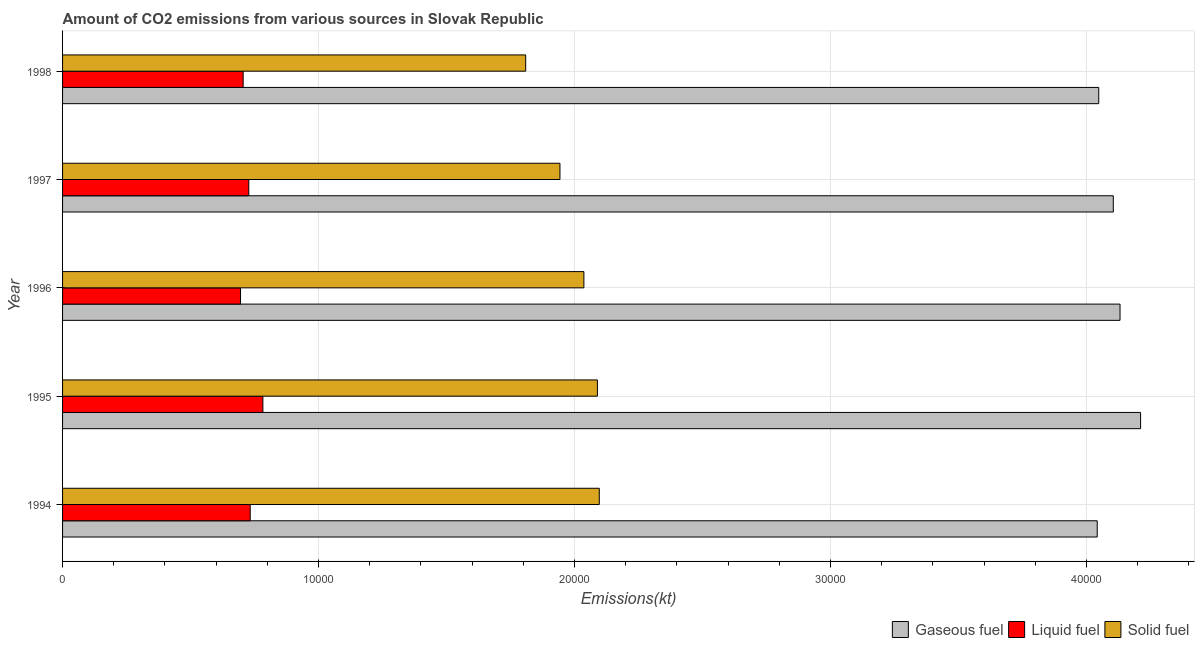How many different coloured bars are there?
Ensure brevity in your answer.  3. Are the number of bars per tick equal to the number of legend labels?
Make the answer very short. Yes. What is the amount of co2 emissions from gaseous fuel in 1997?
Your answer should be very brief. 4.10e+04. Across all years, what is the maximum amount of co2 emissions from liquid fuel?
Ensure brevity in your answer.  7825.38. Across all years, what is the minimum amount of co2 emissions from gaseous fuel?
Your answer should be very brief. 4.04e+04. What is the total amount of co2 emissions from liquid fuel in the graph?
Offer a very short reply. 3.64e+04. What is the difference between the amount of co2 emissions from solid fuel in 1997 and that in 1998?
Your response must be concise. 1338.45. What is the difference between the amount of co2 emissions from liquid fuel in 1997 and the amount of co2 emissions from gaseous fuel in 1994?
Offer a terse response. -3.31e+04. What is the average amount of co2 emissions from solid fuel per year?
Offer a very short reply. 2.00e+04. In the year 1997, what is the difference between the amount of co2 emissions from gaseous fuel and amount of co2 emissions from liquid fuel?
Provide a succinct answer. 3.38e+04. In how many years, is the amount of co2 emissions from solid fuel greater than 6000 kt?
Offer a terse response. 5. What is the ratio of the amount of co2 emissions from solid fuel in 1995 to that in 1997?
Give a very brief answer. 1.07. Is the difference between the amount of co2 emissions from solid fuel in 1994 and 1997 greater than the difference between the amount of co2 emissions from liquid fuel in 1994 and 1997?
Your answer should be compact. Yes. What is the difference between the highest and the second highest amount of co2 emissions from gaseous fuel?
Provide a succinct answer. 803.07. What is the difference between the highest and the lowest amount of co2 emissions from solid fuel?
Your response must be concise. 2874.93. In how many years, is the amount of co2 emissions from gaseous fuel greater than the average amount of co2 emissions from gaseous fuel taken over all years?
Your answer should be very brief. 2. What does the 1st bar from the top in 1994 represents?
Your answer should be very brief. Solid fuel. What does the 3rd bar from the bottom in 1995 represents?
Make the answer very short. Solid fuel. How many bars are there?
Your answer should be very brief. 15. Are all the bars in the graph horizontal?
Provide a short and direct response. Yes. How many years are there in the graph?
Offer a very short reply. 5. What is the difference between two consecutive major ticks on the X-axis?
Offer a very short reply. 10000. Does the graph contain grids?
Keep it short and to the point. Yes. How many legend labels are there?
Offer a terse response. 3. What is the title of the graph?
Offer a terse response. Amount of CO2 emissions from various sources in Slovak Republic. What is the label or title of the X-axis?
Ensure brevity in your answer.  Emissions(kt). What is the Emissions(kt) in Gaseous fuel in 1994?
Your response must be concise. 4.04e+04. What is the Emissions(kt) in Liquid fuel in 1994?
Offer a terse response. 7330.33. What is the Emissions(kt) of Solid fuel in 1994?
Your answer should be compact. 2.10e+04. What is the Emissions(kt) in Gaseous fuel in 1995?
Your answer should be compact. 4.21e+04. What is the Emissions(kt) in Liquid fuel in 1995?
Provide a short and direct response. 7825.38. What is the Emissions(kt) in Solid fuel in 1995?
Your answer should be compact. 2.09e+04. What is the Emissions(kt) of Gaseous fuel in 1996?
Your response must be concise. 4.13e+04. What is the Emissions(kt) of Liquid fuel in 1996?
Give a very brief answer. 6952.63. What is the Emissions(kt) in Solid fuel in 1996?
Ensure brevity in your answer.  2.04e+04. What is the Emissions(kt) of Gaseous fuel in 1997?
Your answer should be compact. 4.10e+04. What is the Emissions(kt) in Liquid fuel in 1997?
Your response must be concise. 7275.33. What is the Emissions(kt) in Solid fuel in 1997?
Your response must be concise. 1.94e+04. What is the Emissions(kt) of Gaseous fuel in 1998?
Offer a very short reply. 4.05e+04. What is the Emissions(kt) in Liquid fuel in 1998?
Your response must be concise. 7055.31. What is the Emissions(kt) of Solid fuel in 1998?
Make the answer very short. 1.81e+04. Across all years, what is the maximum Emissions(kt) of Gaseous fuel?
Provide a succinct answer. 4.21e+04. Across all years, what is the maximum Emissions(kt) of Liquid fuel?
Your response must be concise. 7825.38. Across all years, what is the maximum Emissions(kt) in Solid fuel?
Give a very brief answer. 2.10e+04. Across all years, what is the minimum Emissions(kt) in Gaseous fuel?
Your answer should be very brief. 4.04e+04. Across all years, what is the minimum Emissions(kt) in Liquid fuel?
Provide a short and direct response. 6952.63. Across all years, what is the minimum Emissions(kt) of Solid fuel?
Provide a short and direct response. 1.81e+04. What is the total Emissions(kt) of Gaseous fuel in the graph?
Your response must be concise. 2.05e+05. What is the total Emissions(kt) in Liquid fuel in the graph?
Offer a very short reply. 3.64e+04. What is the total Emissions(kt) in Solid fuel in the graph?
Offer a very short reply. 9.98e+04. What is the difference between the Emissions(kt) of Gaseous fuel in 1994 and that in 1995?
Your response must be concise. -1694.15. What is the difference between the Emissions(kt) of Liquid fuel in 1994 and that in 1995?
Offer a very short reply. -495.05. What is the difference between the Emissions(kt) of Solid fuel in 1994 and that in 1995?
Make the answer very short. 73.34. What is the difference between the Emissions(kt) in Gaseous fuel in 1994 and that in 1996?
Provide a short and direct response. -891.08. What is the difference between the Emissions(kt) in Liquid fuel in 1994 and that in 1996?
Your answer should be very brief. 377.7. What is the difference between the Emissions(kt) in Solid fuel in 1994 and that in 1996?
Provide a succinct answer. 601.39. What is the difference between the Emissions(kt) of Gaseous fuel in 1994 and that in 1997?
Offer a very short reply. -627.06. What is the difference between the Emissions(kt) in Liquid fuel in 1994 and that in 1997?
Offer a very short reply. 55.01. What is the difference between the Emissions(kt) of Solid fuel in 1994 and that in 1997?
Give a very brief answer. 1536.47. What is the difference between the Emissions(kt) of Gaseous fuel in 1994 and that in 1998?
Ensure brevity in your answer.  -58.67. What is the difference between the Emissions(kt) of Liquid fuel in 1994 and that in 1998?
Provide a succinct answer. 275.02. What is the difference between the Emissions(kt) in Solid fuel in 1994 and that in 1998?
Ensure brevity in your answer.  2874.93. What is the difference between the Emissions(kt) of Gaseous fuel in 1995 and that in 1996?
Your answer should be very brief. 803.07. What is the difference between the Emissions(kt) in Liquid fuel in 1995 and that in 1996?
Your response must be concise. 872.75. What is the difference between the Emissions(kt) in Solid fuel in 1995 and that in 1996?
Give a very brief answer. 528.05. What is the difference between the Emissions(kt) in Gaseous fuel in 1995 and that in 1997?
Provide a short and direct response. 1067.1. What is the difference between the Emissions(kt) in Liquid fuel in 1995 and that in 1997?
Offer a terse response. 550.05. What is the difference between the Emissions(kt) in Solid fuel in 1995 and that in 1997?
Your answer should be very brief. 1463.13. What is the difference between the Emissions(kt) in Gaseous fuel in 1995 and that in 1998?
Make the answer very short. 1635.48. What is the difference between the Emissions(kt) in Liquid fuel in 1995 and that in 1998?
Offer a terse response. 770.07. What is the difference between the Emissions(kt) in Solid fuel in 1995 and that in 1998?
Give a very brief answer. 2801.59. What is the difference between the Emissions(kt) of Gaseous fuel in 1996 and that in 1997?
Your answer should be very brief. 264.02. What is the difference between the Emissions(kt) in Liquid fuel in 1996 and that in 1997?
Your answer should be very brief. -322.7. What is the difference between the Emissions(kt) in Solid fuel in 1996 and that in 1997?
Your response must be concise. 935.09. What is the difference between the Emissions(kt) in Gaseous fuel in 1996 and that in 1998?
Keep it short and to the point. 832.41. What is the difference between the Emissions(kt) in Liquid fuel in 1996 and that in 1998?
Give a very brief answer. -102.68. What is the difference between the Emissions(kt) in Solid fuel in 1996 and that in 1998?
Make the answer very short. 2273.54. What is the difference between the Emissions(kt) of Gaseous fuel in 1997 and that in 1998?
Ensure brevity in your answer.  568.38. What is the difference between the Emissions(kt) in Liquid fuel in 1997 and that in 1998?
Keep it short and to the point. 220.02. What is the difference between the Emissions(kt) in Solid fuel in 1997 and that in 1998?
Offer a very short reply. 1338.45. What is the difference between the Emissions(kt) of Gaseous fuel in 1994 and the Emissions(kt) of Liquid fuel in 1995?
Keep it short and to the point. 3.26e+04. What is the difference between the Emissions(kt) in Gaseous fuel in 1994 and the Emissions(kt) in Solid fuel in 1995?
Your answer should be very brief. 1.95e+04. What is the difference between the Emissions(kt) in Liquid fuel in 1994 and the Emissions(kt) in Solid fuel in 1995?
Give a very brief answer. -1.36e+04. What is the difference between the Emissions(kt) in Gaseous fuel in 1994 and the Emissions(kt) in Liquid fuel in 1996?
Your response must be concise. 3.35e+04. What is the difference between the Emissions(kt) in Gaseous fuel in 1994 and the Emissions(kt) in Solid fuel in 1996?
Offer a very short reply. 2.01e+04. What is the difference between the Emissions(kt) of Liquid fuel in 1994 and the Emissions(kt) of Solid fuel in 1996?
Offer a terse response. -1.30e+04. What is the difference between the Emissions(kt) in Gaseous fuel in 1994 and the Emissions(kt) in Liquid fuel in 1997?
Offer a very short reply. 3.31e+04. What is the difference between the Emissions(kt) of Gaseous fuel in 1994 and the Emissions(kt) of Solid fuel in 1997?
Your response must be concise. 2.10e+04. What is the difference between the Emissions(kt) of Liquid fuel in 1994 and the Emissions(kt) of Solid fuel in 1997?
Your response must be concise. -1.21e+04. What is the difference between the Emissions(kt) in Gaseous fuel in 1994 and the Emissions(kt) in Liquid fuel in 1998?
Your answer should be compact. 3.34e+04. What is the difference between the Emissions(kt) in Gaseous fuel in 1994 and the Emissions(kt) in Solid fuel in 1998?
Keep it short and to the point. 2.23e+04. What is the difference between the Emissions(kt) in Liquid fuel in 1994 and the Emissions(kt) in Solid fuel in 1998?
Make the answer very short. -1.08e+04. What is the difference between the Emissions(kt) of Gaseous fuel in 1995 and the Emissions(kt) of Liquid fuel in 1996?
Your response must be concise. 3.52e+04. What is the difference between the Emissions(kt) of Gaseous fuel in 1995 and the Emissions(kt) of Solid fuel in 1996?
Your answer should be very brief. 2.17e+04. What is the difference between the Emissions(kt) in Liquid fuel in 1995 and the Emissions(kt) in Solid fuel in 1996?
Ensure brevity in your answer.  -1.25e+04. What is the difference between the Emissions(kt) of Gaseous fuel in 1995 and the Emissions(kt) of Liquid fuel in 1997?
Make the answer very short. 3.48e+04. What is the difference between the Emissions(kt) in Gaseous fuel in 1995 and the Emissions(kt) in Solid fuel in 1997?
Ensure brevity in your answer.  2.27e+04. What is the difference between the Emissions(kt) in Liquid fuel in 1995 and the Emissions(kt) in Solid fuel in 1997?
Your answer should be compact. -1.16e+04. What is the difference between the Emissions(kt) in Gaseous fuel in 1995 and the Emissions(kt) in Liquid fuel in 1998?
Offer a terse response. 3.51e+04. What is the difference between the Emissions(kt) in Gaseous fuel in 1995 and the Emissions(kt) in Solid fuel in 1998?
Provide a short and direct response. 2.40e+04. What is the difference between the Emissions(kt) of Liquid fuel in 1995 and the Emissions(kt) of Solid fuel in 1998?
Your response must be concise. -1.03e+04. What is the difference between the Emissions(kt) in Gaseous fuel in 1996 and the Emissions(kt) in Liquid fuel in 1997?
Keep it short and to the point. 3.40e+04. What is the difference between the Emissions(kt) of Gaseous fuel in 1996 and the Emissions(kt) of Solid fuel in 1997?
Your answer should be compact. 2.19e+04. What is the difference between the Emissions(kt) of Liquid fuel in 1996 and the Emissions(kt) of Solid fuel in 1997?
Your answer should be compact. -1.25e+04. What is the difference between the Emissions(kt) in Gaseous fuel in 1996 and the Emissions(kt) in Liquid fuel in 1998?
Give a very brief answer. 3.43e+04. What is the difference between the Emissions(kt) in Gaseous fuel in 1996 and the Emissions(kt) in Solid fuel in 1998?
Give a very brief answer. 2.32e+04. What is the difference between the Emissions(kt) of Liquid fuel in 1996 and the Emissions(kt) of Solid fuel in 1998?
Keep it short and to the point. -1.11e+04. What is the difference between the Emissions(kt) in Gaseous fuel in 1997 and the Emissions(kt) in Liquid fuel in 1998?
Give a very brief answer. 3.40e+04. What is the difference between the Emissions(kt) of Gaseous fuel in 1997 and the Emissions(kt) of Solid fuel in 1998?
Offer a very short reply. 2.30e+04. What is the difference between the Emissions(kt) of Liquid fuel in 1997 and the Emissions(kt) of Solid fuel in 1998?
Your response must be concise. -1.08e+04. What is the average Emissions(kt) in Gaseous fuel per year?
Make the answer very short. 4.11e+04. What is the average Emissions(kt) in Liquid fuel per year?
Offer a very short reply. 7287.8. What is the average Emissions(kt) in Solid fuel per year?
Give a very brief answer. 2.00e+04. In the year 1994, what is the difference between the Emissions(kt) in Gaseous fuel and Emissions(kt) in Liquid fuel?
Give a very brief answer. 3.31e+04. In the year 1994, what is the difference between the Emissions(kt) in Gaseous fuel and Emissions(kt) in Solid fuel?
Provide a short and direct response. 1.95e+04. In the year 1994, what is the difference between the Emissions(kt) in Liquid fuel and Emissions(kt) in Solid fuel?
Your response must be concise. -1.36e+04. In the year 1995, what is the difference between the Emissions(kt) of Gaseous fuel and Emissions(kt) of Liquid fuel?
Your response must be concise. 3.43e+04. In the year 1995, what is the difference between the Emissions(kt) of Gaseous fuel and Emissions(kt) of Solid fuel?
Give a very brief answer. 2.12e+04. In the year 1995, what is the difference between the Emissions(kt) in Liquid fuel and Emissions(kt) in Solid fuel?
Ensure brevity in your answer.  -1.31e+04. In the year 1996, what is the difference between the Emissions(kt) of Gaseous fuel and Emissions(kt) of Liquid fuel?
Make the answer very short. 3.44e+04. In the year 1996, what is the difference between the Emissions(kt) of Gaseous fuel and Emissions(kt) of Solid fuel?
Keep it short and to the point. 2.09e+04. In the year 1996, what is the difference between the Emissions(kt) in Liquid fuel and Emissions(kt) in Solid fuel?
Provide a short and direct response. -1.34e+04. In the year 1997, what is the difference between the Emissions(kt) in Gaseous fuel and Emissions(kt) in Liquid fuel?
Provide a succinct answer. 3.38e+04. In the year 1997, what is the difference between the Emissions(kt) in Gaseous fuel and Emissions(kt) in Solid fuel?
Keep it short and to the point. 2.16e+04. In the year 1997, what is the difference between the Emissions(kt) of Liquid fuel and Emissions(kt) of Solid fuel?
Ensure brevity in your answer.  -1.22e+04. In the year 1998, what is the difference between the Emissions(kt) of Gaseous fuel and Emissions(kt) of Liquid fuel?
Make the answer very short. 3.34e+04. In the year 1998, what is the difference between the Emissions(kt) in Gaseous fuel and Emissions(kt) in Solid fuel?
Offer a very short reply. 2.24e+04. In the year 1998, what is the difference between the Emissions(kt) of Liquid fuel and Emissions(kt) of Solid fuel?
Your response must be concise. -1.10e+04. What is the ratio of the Emissions(kt) of Gaseous fuel in 1994 to that in 1995?
Your answer should be compact. 0.96. What is the ratio of the Emissions(kt) of Liquid fuel in 1994 to that in 1995?
Give a very brief answer. 0.94. What is the ratio of the Emissions(kt) in Gaseous fuel in 1994 to that in 1996?
Ensure brevity in your answer.  0.98. What is the ratio of the Emissions(kt) of Liquid fuel in 1994 to that in 1996?
Your answer should be compact. 1.05. What is the ratio of the Emissions(kt) of Solid fuel in 1994 to that in 1996?
Offer a terse response. 1.03. What is the ratio of the Emissions(kt) in Gaseous fuel in 1994 to that in 1997?
Keep it short and to the point. 0.98. What is the ratio of the Emissions(kt) of Liquid fuel in 1994 to that in 1997?
Offer a terse response. 1.01. What is the ratio of the Emissions(kt) of Solid fuel in 1994 to that in 1997?
Offer a terse response. 1.08. What is the ratio of the Emissions(kt) of Liquid fuel in 1994 to that in 1998?
Your response must be concise. 1.04. What is the ratio of the Emissions(kt) in Solid fuel in 1994 to that in 1998?
Ensure brevity in your answer.  1.16. What is the ratio of the Emissions(kt) of Gaseous fuel in 1995 to that in 1996?
Keep it short and to the point. 1.02. What is the ratio of the Emissions(kt) in Liquid fuel in 1995 to that in 1996?
Your answer should be very brief. 1.13. What is the ratio of the Emissions(kt) in Solid fuel in 1995 to that in 1996?
Your answer should be compact. 1.03. What is the ratio of the Emissions(kt) of Liquid fuel in 1995 to that in 1997?
Offer a very short reply. 1.08. What is the ratio of the Emissions(kt) in Solid fuel in 1995 to that in 1997?
Your answer should be very brief. 1.08. What is the ratio of the Emissions(kt) in Gaseous fuel in 1995 to that in 1998?
Keep it short and to the point. 1.04. What is the ratio of the Emissions(kt) of Liquid fuel in 1995 to that in 1998?
Your answer should be very brief. 1.11. What is the ratio of the Emissions(kt) of Solid fuel in 1995 to that in 1998?
Provide a short and direct response. 1.15. What is the ratio of the Emissions(kt) of Gaseous fuel in 1996 to that in 1997?
Ensure brevity in your answer.  1.01. What is the ratio of the Emissions(kt) in Liquid fuel in 1996 to that in 1997?
Ensure brevity in your answer.  0.96. What is the ratio of the Emissions(kt) in Solid fuel in 1996 to that in 1997?
Your response must be concise. 1.05. What is the ratio of the Emissions(kt) of Gaseous fuel in 1996 to that in 1998?
Ensure brevity in your answer.  1.02. What is the ratio of the Emissions(kt) in Liquid fuel in 1996 to that in 1998?
Offer a very short reply. 0.99. What is the ratio of the Emissions(kt) of Solid fuel in 1996 to that in 1998?
Ensure brevity in your answer.  1.13. What is the ratio of the Emissions(kt) in Gaseous fuel in 1997 to that in 1998?
Give a very brief answer. 1.01. What is the ratio of the Emissions(kt) in Liquid fuel in 1997 to that in 1998?
Provide a succinct answer. 1.03. What is the ratio of the Emissions(kt) of Solid fuel in 1997 to that in 1998?
Provide a succinct answer. 1.07. What is the difference between the highest and the second highest Emissions(kt) in Gaseous fuel?
Ensure brevity in your answer.  803.07. What is the difference between the highest and the second highest Emissions(kt) of Liquid fuel?
Offer a very short reply. 495.05. What is the difference between the highest and the second highest Emissions(kt) in Solid fuel?
Your answer should be very brief. 73.34. What is the difference between the highest and the lowest Emissions(kt) in Gaseous fuel?
Provide a succinct answer. 1694.15. What is the difference between the highest and the lowest Emissions(kt) of Liquid fuel?
Keep it short and to the point. 872.75. What is the difference between the highest and the lowest Emissions(kt) of Solid fuel?
Give a very brief answer. 2874.93. 